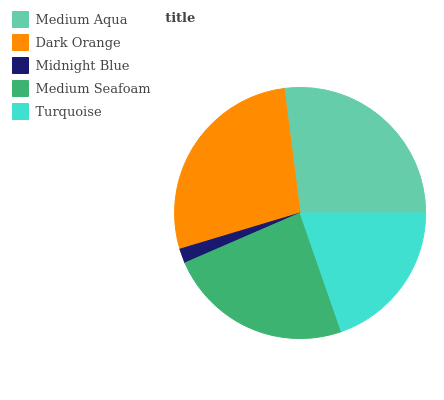Is Midnight Blue the minimum?
Answer yes or no. Yes. Is Dark Orange the maximum?
Answer yes or no. Yes. Is Dark Orange the minimum?
Answer yes or no. No. Is Midnight Blue the maximum?
Answer yes or no. No. Is Dark Orange greater than Midnight Blue?
Answer yes or no. Yes. Is Midnight Blue less than Dark Orange?
Answer yes or no. Yes. Is Midnight Blue greater than Dark Orange?
Answer yes or no. No. Is Dark Orange less than Midnight Blue?
Answer yes or no. No. Is Medium Seafoam the high median?
Answer yes or no. Yes. Is Medium Seafoam the low median?
Answer yes or no. Yes. Is Turquoise the high median?
Answer yes or no. No. Is Medium Aqua the low median?
Answer yes or no. No. 